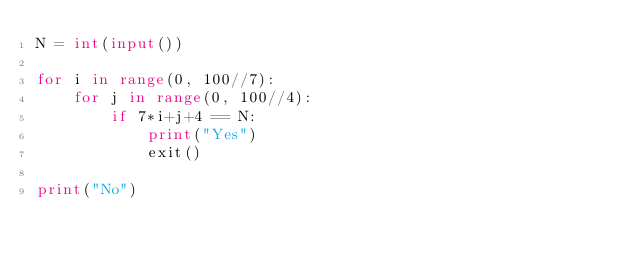<code> <loc_0><loc_0><loc_500><loc_500><_Python_>N = int(input())

for i in range(0, 100//7):
    for j in range(0, 100//4):
        if 7*i+j+4 == N:
            print("Yes")
            exit()

print("No")</code> 